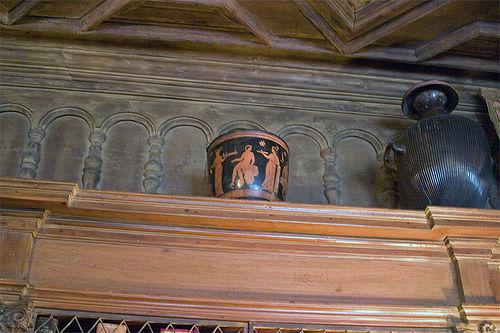Question: where was picture taken?
Choices:
A. On the mantle.
B. On a mountain.
C. At a skate park.
D. At the zoo.
Answer with the letter. Answer: A Question: what color is the wood?
Choices:
A. Light brown.
B. Dark brown.
C. Brown.
D. Black.
Answer with the letter. Answer: C Question: what are the objects?
Choices:
A. Vases.
B. Bowls.
C. Plates.
D. Cups.
Answer with the letter. Answer: A Question: how many vases are there?
Choices:
A. Three.
B. One.
C. Two.
D. Four.
Answer with the letter. Answer: C Question: why is vase reflecting?
Choices:
A. It is shiny.
B. It is metal.
C. Lights.
D. It is in the sunshine.
Answer with the letter. Answer: C 